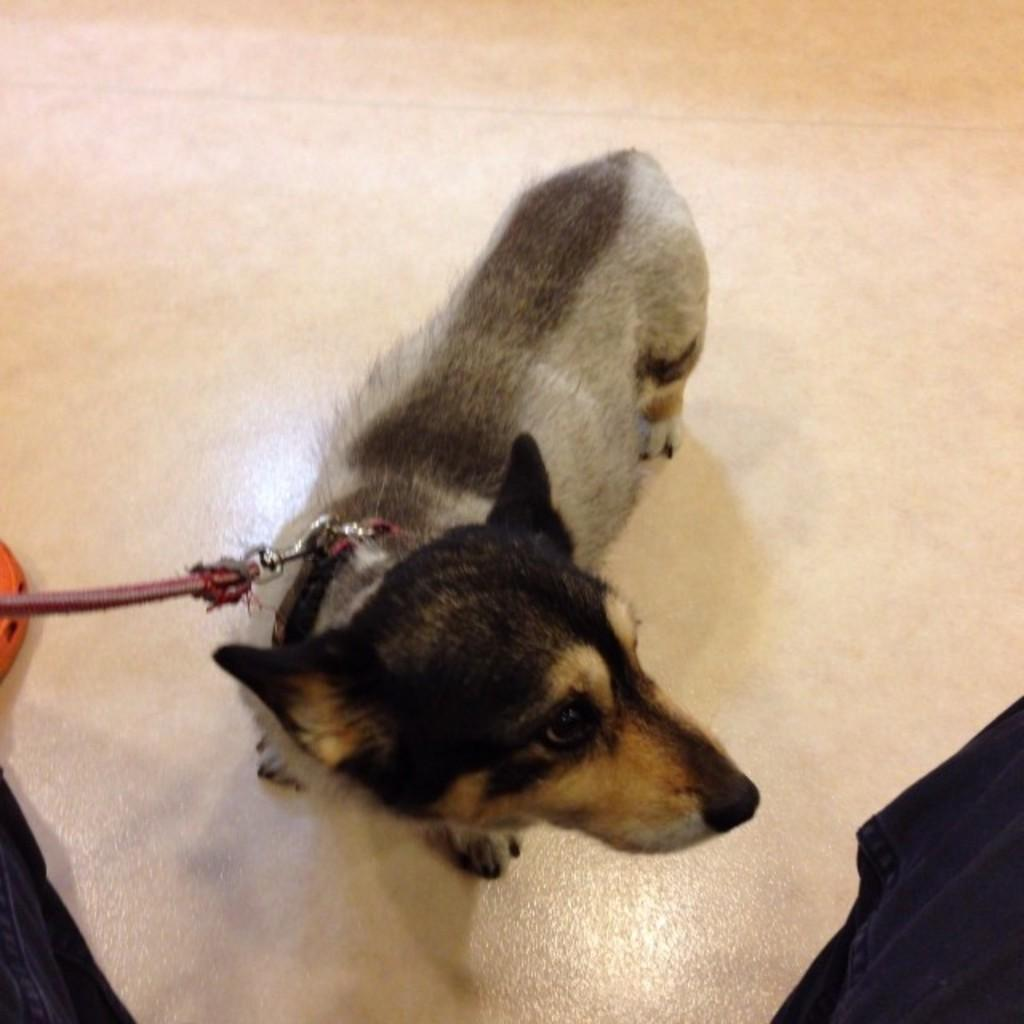What type of animal is present in the image? There is a dog in the image. Where is the dog located in the image? The dog is standing on the floor. What type of connection can be seen between the dog and the water in the image? There is no water present in the image, and therefore no connection between the dog and water can be observed. 